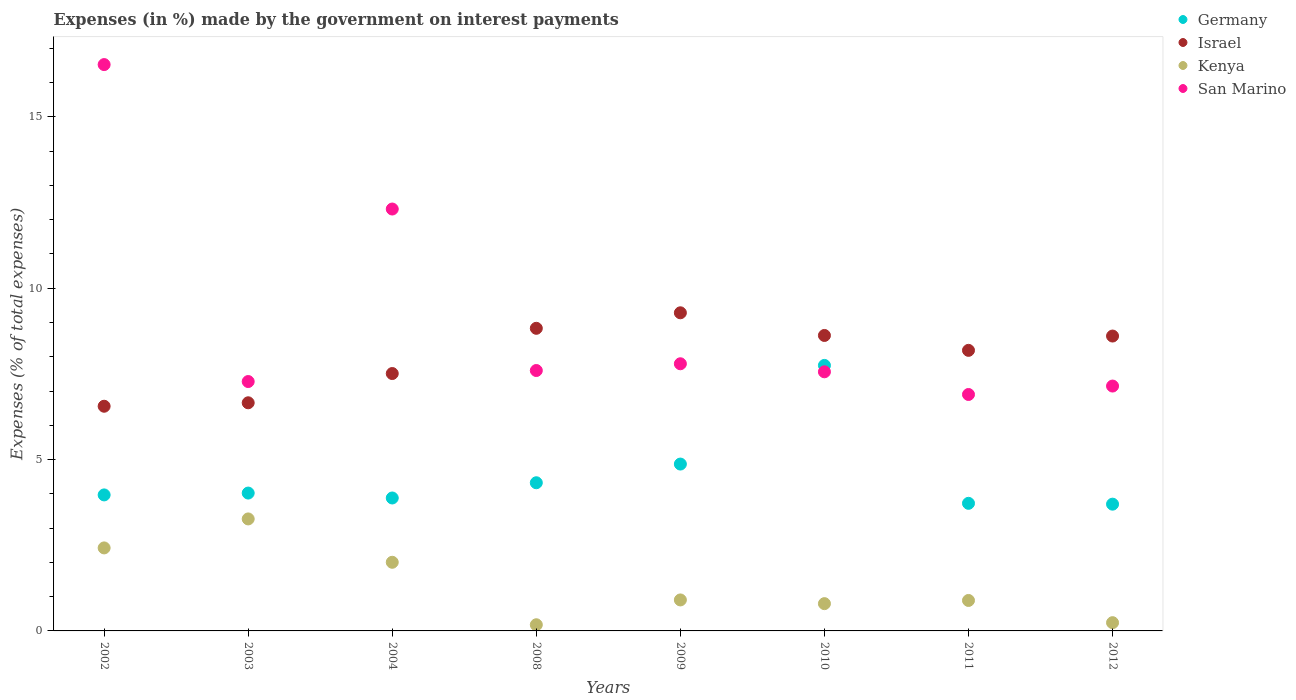How many different coloured dotlines are there?
Your response must be concise. 4. Is the number of dotlines equal to the number of legend labels?
Ensure brevity in your answer.  Yes. What is the percentage of expenses made by the government on interest payments in Israel in 2004?
Ensure brevity in your answer.  7.51. Across all years, what is the maximum percentage of expenses made by the government on interest payments in San Marino?
Your response must be concise. 16.53. Across all years, what is the minimum percentage of expenses made by the government on interest payments in Israel?
Give a very brief answer. 6.56. What is the total percentage of expenses made by the government on interest payments in San Marino in the graph?
Provide a succinct answer. 73.12. What is the difference between the percentage of expenses made by the government on interest payments in Germany in 2004 and that in 2009?
Provide a short and direct response. -0.99. What is the difference between the percentage of expenses made by the government on interest payments in San Marino in 2011 and the percentage of expenses made by the government on interest payments in Israel in 2003?
Provide a succinct answer. 0.24. What is the average percentage of expenses made by the government on interest payments in Kenya per year?
Provide a succinct answer. 1.34. In the year 2008, what is the difference between the percentage of expenses made by the government on interest payments in Kenya and percentage of expenses made by the government on interest payments in San Marino?
Provide a short and direct response. -7.42. What is the ratio of the percentage of expenses made by the government on interest payments in Israel in 2002 to that in 2008?
Your answer should be very brief. 0.74. Is the percentage of expenses made by the government on interest payments in San Marino in 2003 less than that in 2012?
Make the answer very short. No. What is the difference between the highest and the second highest percentage of expenses made by the government on interest payments in San Marino?
Offer a very short reply. 4.22. What is the difference between the highest and the lowest percentage of expenses made by the government on interest payments in Israel?
Your response must be concise. 2.73. In how many years, is the percentage of expenses made by the government on interest payments in San Marino greater than the average percentage of expenses made by the government on interest payments in San Marino taken over all years?
Your response must be concise. 2. Is the sum of the percentage of expenses made by the government on interest payments in Germany in 2011 and 2012 greater than the maximum percentage of expenses made by the government on interest payments in Kenya across all years?
Keep it short and to the point. Yes. Is it the case that in every year, the sum of the percentage of expenses made by the government on interest payments in Israel and percentage of expenses made by the government on interest payments in Germany  is greater than the percentage of expenses made by the government on interest payments in Kenya?
Give a very brief answer. Yes. Is the percentage of expenses made by the government on interest payments in Germany strictly greater than the percentage of expenses made by the government on interest payments in Israel over the years?
Offer a terse response. No. Is the percentage of expenses made by the government on interest payments in Kenya strictly less than the percentage of expenses made by the government on interest payments in Germany over the years?
Give a very brief answer. Yes. Does the graph contain any zero values?
Ensure brevity in your answer.  No. Where does the legend appear in the graph?
Ensure brevity in your answer.  Top right. How many legend labels are there?
Offer a terse response. 4. What is the title of the graph?
Provide a succinct answer. Expenses (in %) made by the government on interest payments. What is the label or title of the X-axis?
Provide a succinct answer. Years. What is the label or title of the Y-axis?
Give a very brief answer. Expenses (% of total expenses). What is the Expenses (% of total expenses) of Germany in 2002?
Make the answer very short. 3.97. What is the Expenses (% of total expenses) in Israel in 2002?
Make the answer very short. 6.56. What is the Expenses (% of total expenses) in Kenya in 2002?
Offer a very short reply. 2.42. What is the Expenses (% of total expenses) in San Marino in 2002?
Give a very brief answer. 16.53. What is the Expenses (% of total expenses) of Germany in 2003?
Give a very brief answer. 4.02. What is the Expenses (% of total expenses) of Israel in 2003?
Ensure brevity in your answer.  6.66. What is the Expenses (% of total expenses) in Kenya in 2003?
Offer a terse response. 3.27. What is the Expenses (% of total expenses) of San Marino in 2003?
Your response must be concise. 7.28. What is the Expenses (% of total expenses) of Germany in 2004?
Keep it short and to the point. 3.88. What is the Expenses (% of total expenses) of Israel in 2004?
Make the answer very short. 7.51. What is the Expenses (% of total expenses) of Kenya in 2004?
Keep it short and to the point. 2. What is the Expenses (% of total expenses) of San Marino in 2004?
Make the answer very short. 12.31. What is the Expenses (% of total expenses) of Germany in 2008?
Offer a very short reply. 4.32. What is the Expenses (% of total expenses) in Israel in 2008?
Your response must be concise. 8.83. What is the Expenses (% of total expenses) in Kenya in 2008?
Keep it short and to the point. 0.18. What is the Expenses (% of total expenses) in San Marino in 2008?
Offer a very short reply. 7.6. What is the Expenses (% of total expenses) in Germany in 2009?
Provide a short and direct response. 4.87. What is the Expenses (% of total expenses) of Israel in 2009?
Your answer should be very brief. 9.28. What is the Expenses (% of total expenses) of Kenya in 2009?
Offer a terse response. 0.9. What is the Expenses (% of total expenses) in San Marino in 2009?
Make the answer very short. 7.8. What is the Expenses (% of total expenses) of Germany in 2010?
Offer a terse response. 7.75. What is the Expenses (% of total expenses) in Israel in 2010?
Your response must be concise. 8.62. What is the Expenses (% of total expenses) in Kenya in 2010?
Keep it short and to the point. 0.8. What is the Expenses (% of total expenses) of San Marino in 2010?
Offer a very short reply. 7.56. What is the Expenses (% of total expenses) of Germany in 2011?
Ensure brevity in your answer.  3.72. What is the Expenses (% of total expenses) in Israel in 2011?
Offer a very short reply. 8.19. What is the Expenses (% of total expenses) in Kenya in 2011?
Give a very brief answer. 0.89. What is the Expenses (% of total expenses) of San Marino in 2011?
Offer a terse response. 6.9. What is the Expenses (% of total expenses) of Germany in 2012?
Give a very brief answer. 3.7. What is the Expenses (% of total expenses) in Israel in 2012?
Make the answer very short. 8.61. What is the Expenses (% of total expenses) in Kenya in 2012?
Make the answer very short. 0.24. What is the Expenses (% of total expenses) of San Marino in 2012?
Make the answer very short. 7.15. Across all years, what is the maximum Expenses (% of total expenses) in Germany?
Your answer should be compact. 7.75. Across all years, what is the maximum Expenses (% of total expenses) of Israel?
Offer a terse response. 9.28. Across all years, what is the maximum Expenses (% of total expenses) of Kenya?
Keep it short and to the point. 3.27. Across all years, what is the maximum Expenses (% of total expenses) in San Marino?
Offer a very short reply. 16.53. Across all years, what is the minimum Expenses (% of total expenses) in Germany?
Give a very brief answer. 3.7. Across all years, what is the minimum Expenses (% of total expenses) of Israel?
Offer a terse response. 6.56. Across all years, what is the minimum Expenses (% of total expenses) of Kenya?
Make the answer very short. 0.18. Across all years, what is the minimum Expenses (% of total expenses) of San Marino?
Your answer should be very brief. 6.9. What is the total Expenses (% of total expenses) in Germany in the graph?
Your answer should be compact. 36.24. What is the total Expenses (% of total expenses) in Israel in the graph?
Make the answer very short. 64.26. What is the total Expenses (% of total expenses) of Kenya in the graph?
Make the answer very short. 10.7. What is the total Expenses (% of total expenses) in San Marino in the graph?
Your response must be concise. 73.12. What is the difference between the Expenses (% of total expenses) in Germany in 2002 and that in 2003?
Keep it short and to the point. -0.05. What is the difference between the Expenses (% of total expenses) of Israel in 2002 and that in 2003?
Offer a terse response. -0.1. What is the difference between the Expenses (% of total expenses) in Kenya in 2002 and that in 2003?
Offer a very short reply. -0.85. What is the difference between the Expenses (% of total expenses) in San Marino in 2002 and that in 2003?
Ensure brevity in your answer.  9.25. What is the difference between the Expenses (% of total expenses) of Germany in 2002 and that in 2004?
Make the answer very short. 0.09. What is the difference between the Expenses (% of total expenses) in Israel in 2002 and that in 2004?
Your answer should be compact. -0.95. What is the difference between the Expenses (% of total expenses) of Kenya in 2002 and that in 2004?
Offer a very short reply. 0.42. What is the difference between the Expenses (% of total expenses) of San Marino in 2002 and that in 2004?
Provide a short and direct response. 4.22. What is the difference between the Expenses (% of total expenses) in Germany in 2002 and that in 2008?
Offer a terse response. -0.35. What is the difference between the Expenses (% of total expenses) of Israel in 2002 and that in 2008?
Ensure brevity in your answer.  -2.27. What is the difference between the Expenses (% of total expenses) in Kenya in 2002 and that in 2008?
Give a very brief answer. 2.24. What is the difference between the Expenses (% of total expenses) in San Marino in 2002 and that in 2008?
Provide a short and direct response. 8.93. What is the difference between the Expenses (% of total expenses) of Germany in 2002 and that in 2009?
Your response must be concise. -0.9. What is the difference between the Expenses (% of total expenses) of Israel in 2002 and that in 2009?
Give a very brief answer. -2.73. What is the difference between the Expenses (% of total expenses) of Kenya in 2002 and that in 2009?
Ensure brevity in your answer.  1.52. What is the difference between the Expenses (% of total expenses) of San Marino in 2002 and that in 2009?
Offer a very short reply. 8.73. What is the difference between the Expenses (% of total expenses) in Germany in 2002 and that in 2010?
Give a very brief answer. -3.78. What is the difference between the Expenses (% of total expenses) of Israel in 2002 and that in 2010?
Provide a succinct answer. -2.07. What is the difference between the Expenses (% of total expenses) of Kenya in 2002 and that in 2010?
Your answer should be compact. 1.63. What is the difference between the Expenses (% of total expenses) of San Marino in 2002 and that in 2010?
Give a very brief answer. 8.97. What is the difference between the Expenses (% of total expenses) in Germany in 2002 and that in 2011?
Your response must be concise. 0.25. What is the difference between the Expenses (% of total expenses) in Israel in 2002 and that in 2011?
Provide a short and direct response. -1.63. What is the difference between the Expenses (% of total expenses) in Kenya in 2002 and that in 2011?
Make the answer very short. 1.53. What is the difference between the Expenses (% of total expenses) of San Marino in 2002 and that in 2011?
Provide a short and direct response. 9.63. What is the difference between the Expenses (% of total expenses) in Germany in 2002 and that in 2012?
Offer a very short reply. 0.27. What is the difference between the Expenses (% of total expenses) in Israel in 2002 and that in 2012?
Make the answer very short. -2.05. What is the difference between the Expenses (% of total expenses) of Kenya in 2002 and that in 2012?
Your answer should be very brief. 2.18. What is the difference between the Expenses (% of total expenses) of San Marino in 2002 and that in 2012?
Give a very brief answer. 9.38. What is the difference between the Expenses (% of total expenses) of Germany in 2003 and that in 2004?
Provide a succinct answer. 0.14. What is the difference between the Expenses (% of total expenses) in Israel in 2003 and that in 2004?
Offer a very short reply. -0.85. What is the difference between the Expenses (% of total expenses) of Kenya in 2003 and that in 2004?
Make the answer very short. 1.27. What is the difference between the Expenses (% of total expenses) of San Marino in 2003 and that in 2004?
Provide a short and direct response. -5.03. What is the difference between the Expenses (% of total expenses) of Germany in 2003 and that in 2008?
Your answer should be very brief. -0.3. What is the difference between the Expenses (% of total expenses) of Israel in 2003 and that in 2008?
Offer a terse response. -2.17. What is the difference between the Expenses (% of total expenses) of Kenya in 2003 and that in 2008?
Offer a very short reply. 3.09. What is the difference between the Expenses (% of total expenses) in San Marino in 2003 and that in 2008?
Offer a very short reply. -0.32. What is the difference between the Expenses (% of total expenses) in Germany in 2003 and that in 2009?
Offer a very short reply. -0.85. What is the difference between the Expenses (% of total expenses) in Israel in 2003 and that in 2009?
Give a very brief answer. -2.63. What is the difference between the Expenses (% of total expenses) in Kenya in 2003 and that in 2009?
Make the answer very short. 2.36. What is the difference between the Expenses (% of total expenses) in San Marino in 2003 and that in 2009?
Your response must be concise. -0.52. What is the difference between the Expenses (% of total expenses) of Germany in 2003 and that in 2010?
Make the answer very short. -3.73. What is the difference between the Expenses (% of total expenses) of Israel in 2003 and that in 2010?
Ensure brevity in your answer.  -1.96. What is the difference between the Expenses (% of total expenses) of Kenya in 2003 and that in 2010?
Your answer should be compact. 2.47. What is the difference between the Expenses (% of total expenses) in San Marino in 2003 and that in 2010?
Your response must be concise. -0.28. What is the difference between the Expenses (% of total expenses) in Germany in 2003 and that in 2011?
Offer a terse response. 0.3. What is the difference between the Expenses (% of total expenses) of Israel in 2003 and that in 2011?
Offer a very short reply. -1.53. What is the difference between the Expenses (% of total expenses) in Kenya in 2003 and that in 2011?
Your answer should be compact. 2.38. What is the difference between the Expenses (% of total expenses) of San Marino in 2003 and that in 2011?
Offer a very short reply. 0.38. What is the difference between the Expenses (% of total expenses) in Germany in 2003 and that in 2012?
Provide a short and direct response. 0.32. What is the difference between the Expenses (% of total expenses) in Israel in 2003 and that in 2012?
Provide a short and direct response. -1.95. What is the difference between the Expenses (% of total expenses) in Kenya in 2003 and that in 2012?
Offer a very short reply. 3.03. What is the difference between the Expenses (% of total expenses) of San Marino in 2003 and that in 2012?
Your answer should be compact. 0.13. What is the difference between the Expenses (% of total expenses) of Germany in 2004 and that in 2008?
Your answer should be compact. -0.44. What is the difference between the Expenses (% of total expenses) in Israel in 2004 and that in 2008?
Ensure brevity in your answer.  -1.32. What is the difference between the Expenses (% of total expenses) of Kenya in 2004 and that in 2008?
Your answer should be compact. 1.82. What is the difference between the Expenses (% of total expenses) in San Marino in 2004 and that in 2008?
Your answer should be compact. 4.71. What is the difference between the Expenses (% of total expenses) in Germany in 2004 and that in 2009?
Your response must be concise. -0.99. What is the difference between the Expenses (% of total expenses) in Israel in 2004 and that in 2009?
Keep it short and to the point. -1.77. What is the difference between the Expenses (% of total expenses) in Kenya in 2004 and that in 2009?
Provide a succinct answer. 1.1. What is the difference between the Expenses (% of total expenses) of San Marino in 2004 and that in 2009?
Offer a very short reply. 4.52. What is the difference between the Expenses (% of total expenses) in Germany in 2004 and that in 2010?
Your answer should be compact. -3.87. What is the difference between the Expenses (% of total expenses) of Israel in 2004 and that in 2010?
Provide a succinct answer. -1.11. What is the difference between the Expenses (% of total expenses) in Kenya in 2004 and that in 2010?
Your answer should be very brief. 1.21. What is the difference between the Expenses (% of total expenses) in San Marino in 2004 and that in 2010?
Make the answer very short. 4.75. What is the difference between the Expenses (% of total expenses) in Germany in 2004 and that in 2011?
Provide a short and direct response. 0.16. What is the difference between the Expenses (% of total expenses) in Israel in 2004 and that in 2011?
Ensure brevity in your answer.  -0.68. What is the difference between the Expenses (% of total expenses) of Kenya in 2004 and that in 2011?
Give a very brief answer. 1.11. What is the difference between the Expenses (% of total expenses) of San Marino in 2004 and that in 2011?
Offer a very short reply. 5.41. What is the difference between the Expenses (% of total expenses) of Germany in 2004 and that in 2012?
Your response must be concise. 0.18. What is the difference between the Expenses (% of total expenses) in Israel in 2004 and that in 2012?
Ensure brevity in your answer.  -1.09. What is the difference between the Expenses (% of total expenses) of Kenya in 2004 and that in 2012?
Make the answer very short. 1.76. What is the difference between the Expenses (% of total expenses) in San Marino in 2004 and that in 2012?
Your response must be concise. 5.17. What is the difference between the Expenses (% of total expenses) of Germany in 2008 and that in 2009?
Your response must be concise. -0.55. What is the difference between the Expenses (% of total expenses) in Israel in 2008 and that in 2009?
Offer a very short reply. -0.45. What is the difference between the Expenses (% of total expenses) of Kenya in 2008 and that in 2009?
Keep it short and to the point. -0.72. What is the difference between the Expenses (% of total expenses) of San Marino in 2008 and that in 2009?
Your response must be concise. -0.2. What is the difference between the Expenses (% of total expenses) in Germany in 2008 and that in 2010?
Make the answer very short. -3.42. What is the difference between the Expenses (% of total expenses) of Israel in 2008 and that in 2010?
Your answer should be compact. 0.21. What is the difference between the Expenses (% of total expenses) of Kenya in 2008 and that in 2010?
Your answer should be very brief. -0.62. What is the difference between the Expenses (% of total expenses) in San Marino in 2008 and that in 2010?
Offer a very short reply. 0.04. What is the difference between the Expenses (% of total expenses) in Germany in 2008 and that in 2011?
Provide a short and direct response. 0.6. What is the difference between the Expenses (% of total expenses) in Israel in 2008 and that in 2011?
Your answer should be very brief. 0.64. What is the difference between the Expenses (% of total expenses) in Kenya in 2008 and that in 2011?
Your response must be concise. -0.71. What is the difference between the Expenses (% of total expenses) of San Marino in 2008 and that in 2011?
Ensure brevity in your answer.  0.7. What is the difference between the Expenses (% of total expenses) in Germany in 2008 and that in 2012?
Offer a terse response. 0.62. What is the difference between the Expenses (% of total expenses) in Israel in 2008 and that in 2012?
Give a very brief answer. 0.23. What is the difference between the Expenses (% of total expenses) of Kenya in 2008 and that in 2012?
Your answer should be compact. -0.06. What is the difference between the Expenses (% of total expenses) in San Marino in 2008 and that in 2012?
Provide a succinct answer. 0.45. What is the difference between the Expenses (% of total expenses) of Germany in 2009 and that in 2010?
Ensure brevity in your answer.  -2.88. What is the difference between the Expenses (% of total expenses) of Israel in 2009 and that in 2010?
Ensure brevity in your answer.  0.66. What is the difference between the Expenses (% of total expenses) in Kenya in 2009 and that in 2010?
Your response must be concise. 0.11. What is the difference between the Expenses (% of total expenses) of San Marino in 2009 and that in 2010?
Your answer should be very brief. 0.23. What is the difference between the Expenses (% of total expenses) of Germany in 2009 and that in 2011?
Keep it short and to the point. 1.15. What is the difference between the Expenses (% of total expenses) in Israel in 2009 and that in 2011?
Give a very brief answer. 1.1. What is the difference between the Expenses (% of total expenses) in Kenya in 2009 and that in 2011?
Your response must be concise. 0.02. What is the difference between the Expenses (% of total expenses) of San Marino in 2009 and that in 2011?
Provide a succinct answer. 0.9. What is the difference between the Expenses (% of total expenses) in Germany in 2009 and that in 2012?
Your response must be concise. 1.17. What is the difference between the Expenses (% of total expenses) of Israel in 2009 and that in 2012?
Your response must be concise. 0.68. What is the difference between the Expenses (% of total expenses) in Kenya in 2009 and that in 2012?
Provide a short and direct response. 0.66. What is the difference between the Expenses (% of total expenses) in San Marino in 2009 and that in 2012?
Your answer should be compact. 0.65. What is the difference between the Expenses (% of total expenses) of Germany in 2010 and that in 2011?
Offer a terse response. 4.02. What is the difference between the Expenses (% of total expenses) of Israel in 2010 and that in 2011?
Make the answer very short. 0.43. What is the difference between the Expenses (% of total expenses) of Kenya in 2010 and that in 2011?
Ensure brevity in your answer.  -0.09. What is the difference between the Expenses (% of total expenses) of San Marino in 2010 and that in 2011?
Keep it short and to the point. 0.66. What is the difference between the Expenses (% of total expenses) in Germany in 2010 and that in 2012?
Offer a terse response. 4.05. What is the difference between the Expenses (% of total expenses) of Israel in 2010 and that in 2012?
Ensure brevity in your answer.  0.02. What is the difference between the Expenses (% of total expenses) of Kenya in 2010 and that in 2012?
Ensure brevity in your answer.  0.56. What is the difference between the Expenses (% of total expenses) of San Marino in 2010 and that in 2012?
Ensure brevity in your answer.  0.42. What is the difference between the Expenses (% of total expenses) in Germany in 2011 and that in 2012?
Keep it short and to the point. 0.02. What is the difference between the Expenses (% of total expenses) of Israel in 2011 and that in 2012?
Offer a terse response. -0.42. What is the difference between the Expenses (% of total expenses) of Kenya in 2011 and that in 2012?
Offer a terse response. 0.65. What is the difference between the Expenses (% of total expenses) in San Marino in 2011 and that in 2012?
Give a very brief answer. -0.25. What is the difference between the Expenses (% of total expenses) of Germany in 2002 and the Expenses (% of total expenses) of Israel in 2003?
Keep it short and to the point. -2.69. What is the difference between the Expenses (% of total expenses) of Germany in 2002 and the Expenses (% of total expenses) of Kenya in 2003?
Make the answer very short. 0.7. What is the difference between the Expenses (% of total expenses) in Germany in 2002 and the Expenses (% of total expenses) in San Marino in 2003?
Provide a succinct answer. -3.31. What is the difference between the Expenses (% of total expenses) of Israel in 2002 and the Expenses (% of total expenses) of Kenya in 2003?
Your answer should be very brief. 3.29. What is the difference between the Expenses (% of total expenses) of Israel in 2002 and the Expenses (% of total expenses) of San Marino in 2003?
Your response must be concise. -0.72. What is the difference between the Expenses (% of total expenses) in Kenya in 2002 and the Expenses (% of total expenses) in San Marino in 2003?
Offer a terse response. -4.86. What is the difference between the Expenses (% of total expenses) of Germany in 2002 and the Expenses (% of total expenses) of Israel in 2004?
Offer a very short reply. -3.54. What is the difference between the Expenses (% of total expenses) in Germany in 2002 and the Expenses (% of total expenses) in Kenya in 2004?
Your answer should be very brief. 1.97. What is the difference between the Expenses (% of total expenses) of Germany in 2002 and the Expenses (% of total expenses) of San Marino in 2004?
Provide a short and direct response. -8.34. What is the difference between the Expenses (% of total expenses) of Israel in 2002 and the Expenses (% of total expenses) of Kenya in 2004?
Your answer should be compact. 4.55. What is the difference between the Expenses (% of total expenses) of Israel in 2002 and the Expenses (% of total expenses) of San Marino in 2004?
Provide a short and direct response. -5.76. What is the difference between the Expenses (% of total expenses) of Kenya in 2002 and the Expenses (% of total expenses) of San Marino in 2004?
Provide a succinct answer. -9.89. What is the difference between the Expenses (% of total expenses) in Germany in 2002 and the Expenses (% of total expenses) in Israel in 2008?
Offer a very short reply. -4.86. What is the difference between the Expenses (% of total expenses) of Germany in 2002 and the Expenses (% of total expenses) of Kenya in 2008?
Your answer should be compact. 3.79. What is the difference between the Expenses (% of total expenses) of Germany in 2002 and the Expenses (% of total expenses) of San Marino in 2008?
Your answer should be very brief. -3.63. What is the difference between the Expenses (% of total expenses) in Israel in 2002 and the Expenses (% of total expenses) in Kenya in 2008?
Your answer should be compact. 6.38. What is the difference between the Expenses (% of total expenses) of Israel in 2002 and the Expenses (% of total expenses) of San Marino in 2008?
Offer a terse response. -1.04. What is the difference between the Expenses (% of total expenses) of Kenya in 2002 and the Expenses (% of total expenses) of San Marino in 2008?
Make the answer very short. -5.18. What is the difference between the Expenses (% of total expenses) in Germany in 2002 and the Expenses (% of total expenses) in Israel in 2009?
Provide a succinct answer. -5.31. What is the difference between the Expenses (% of total expenses) in Germany in 2002 and the Expenses (% of total expenses) in Kenya in 2009?
Your answer should be compact. 3.06. What is the difference between the Expenses (% of total expenses) of Germany in 2002 and the Expenses (% of total expenses) of San Marino in 2009?
Offer a terse response. -3.83. What is the difference between the Expenses (% of total expenses) of Israel in 2002 and the Expenses (% of total expenses) of Kenya in 2009?
Offer a very short reply. 5.65. What is the difference between the Expenses (% of total expenses) of Israel in 2002 and the Expenses (% of total expenses) of San Marino in 2009?
Make the answer very short. -1.24. What is the difference between the Expenses (% of total expenses) of Kenya in 2002 and the Expenses (% of total expenses) of San Marino in 2009?
Give a very brief answer. -5.37. What is the difference between the Expenses (% of total expenses) in Germany in 2002 and the Expenses (% of total expenses) in Israel in 2010?
Offer a terse response. -4.65. What is the difference between the Expenses (% of total expenses) in Germany in 2002 and the Expenses (% of total expenses) in Kenya in 2010?
Ensure brevity in your answer.  3.17. What is the difference between the Expenses (% of total expenses) of Germany in 2002 and the Expenses (% of total expenses) of San Marino in 2010?
Provide a succinct answer. -3.59. What is the difference between the Expenses (% of total expenses) of Israel in 2002 and the Expenses (% of total expenses) of Kenya in 2010?
Offer a terse response. 5.76. What is the difference between the Expenses (% of total expenses) of Israel in 2002 and the Expenses (% of total expenses) of San Marino in 2010?
Offer a very short reply. -1. What is the difference between the Expenses (% of total expenses) in Kenya in 2002 and the Expenses (% of total expenses) in San Marino in 2010?
Provide a short and direct response. -5.14. What is the difference between the Expenses (% of total expenses) in Germany in 2002 and the Expenses (% of total expenses) in Israel in 2011?
Keep it short and to the point. -4.22. What is the difference between the Expenses (% of total expenses) of Germany in 2002 and the Expenses (% of total expenses) of Kenya in 2011?
Provide a short and direct response. 3.08. What is the difference between the Expenses (% of total expenses) in Germany in 2002 and the Expenses (% of total expenses) in San Marino in 2011?
Your answer should be compact. -2.93. What is the difference between the Expenses (% of total expenses) of Israel in 2002 and the Expenses (% of total expenses) of Kenya in 2011?
Your answer should be compact. 5.67. What is the difference between the Expenses (% of total expenses) in Israel in 2002 and the Expenses (% of total expenses) in San Marino in 2011?
Your answer should be compact. -0.34. What is the difference between the Expenses (% of total expenses) of Kenya in 2002 and the Expenses (% of total expenses) of San Marino in 2011?
Give a very brief answer. -4.48. What is the difference between the Expenses (% of total expenses) of Germany in 2002 and the Expenses (% of total expenses) of Israel in 2012?
Your response must be concise. -4.64. What is the difference between the Expenses (% of total expenses) of Germany in 2002 and the Expenses (% of total expenses) of Kenya in 2012?
Provide a short and direct response. 3.73. What is the difference between the Expenses (% of total expenses) in Germany in 2002 and the Expenses (% of total expenses) in San Marino in 2012?
Offer a very short reply. -3.18. What is the difference between the Expenses (% of total expenses) in Israel in 2002 and the Expenses (% of total expenses) in Kenya in 2012?
Provide a short and direct response. 6.32. What is the difference between the Expenses (% of total expenses) of Israel in 2002 and the Expenses (% of total expenses) of San Marino in 2012?
Your answer should be very brief. -0.59. What is the difference between the Expenses (% of total expenses) of Kenya in 2002 and the Expenses (% of total expenses) of San Marino in 2012?
Offer a very short reply. -4.72. What is the difference between the Expenses (% of total expenses) of Germany in 2003 and the Expenses (% of total expenses) of Israel in 2004?
Provide a short and direct response. -3.49. What is the difference between the Expenses (% of total expenses) of Germany in 2003 and the Expenses (% of total expenses) of Kenya in 2004?
Offer a terse response. 2.02. What is the difference between the Expenses (% of total expenses) in Germany in 2003 and the Expenses (% of total expenses) in San Marino in 2004?
Keep it short and to the point. -8.29. What is the difference between the Expenses (% of total expenses) of Israel in 2003 and the Expenses (% of total expenses) of Kenya in 2004?
Ensure brevity in your answer.  4.65. What is the difference between the Expenses (% of total expenses) of Israel in 2003 and the Expenses (% of total expenses) of San Marino in 2004?
Ensure brevity in your answer.  -5.65. What is the difference between the Expenses (% of total expenses) of Kenya in 2003 and the Expenses (% of total expenses) of San Marino in 2004?
Provide a short and direct response. -9.04. What is the difference between the Expenses (% of total expenses) of Germany in 2003 and the Expenses (% of total expenses) of Israel in 2008?
Your response must be concise. -4.81. What is the difference between the Expenses (% of total expenses) in Germany in 2003 and the Expenses (% of total expenses) in Kenya in 2008?
Ensure brevity in your answer.  3.84. What is the difference between the Expenses (% of total expenses) in Germany in 2003 and the Expenses (% of total expenses) in San Marino in 2008?
Offer a very short reply. -3.58. What is the difference between the Expenses (% of total expenses) of Israel in 2003 and the Expenses (% of total expenses) of Kenya in 2008?
Offer a terse response. 6.48. What is the difference between the Expenses (% of total expenses) of Israel in 2003 and the Expenses (% of total expenses) of San Marino in 2008?
Offer a very short reply. -0.94. What is the difference between the Expenses (% of total expenses) of Kenya in 2003 and the Expenses (% of total expenses) of San Marino in 2008?
Provide a short and direct response. -4.33. What is the difference between the Expenses (% of total expenses) in Germany in 2003 and the Expenses (% of total expenses) in Israel in 2009?
Your answer should be compact. -5.26. What is the difference between the Expenses (% of total expenses) of Germany in 2003 and the Expenses (% of total expenses) of Kenya in 2009?
Keep it short and to the point. 3.12. What is the difference between the Expenses (% of total expenses) of Germany in 2003 and the Expenses (% of total expenses) of San Marino in 2009?
Your answer should be compact. -3.77. What is the difference between the Expenses (% of total expenses) in Israel in 2003 and the Expenses (% of total expenses) in Kenya in 2009?
Ensure brevity in your answer.  5.75. What is the difference between the Expenses (% of total expenses) in Israel in 2003 and the Expenses (% of total expenses) in San Marino in 2009?
Offer a very short reply. -1.14. What is the difference between the Expenses (% of total expenses) of Kenya in 2003 and the Expenses (% of total expenses) of San Marino in 2009?
Ensure brevity in your answer.  -4.53. What is the difference between the Expenses (% of total expenses) in Germany in 2003 and the Expenses (% of total expenses) in Israel in 2010?
Keep it short and to the point. -4.6. What is the difference between the Expenses (% of total expenses) of Germany in 2003 and the Expenses (% of total expenses) of Kenya in 2010?
Ensure brevity in your answer.  3.23. What is the difference between the Expenses (% of total expenses) in Germany in 2003 and the Expenses (% of total expenses) in San Marino in 2010?
Your answer should be very brief. -3.54. What is the difference between the Expenses (% of total expenses) of Israel in 2003 and the Expenses (% of total expenses) of Kenya in 2010?
Ensure brevity in your answer.  5.86. What is the difference between the Expenses (% of total expenses) in Israel in 2003 and the Expenses (% of total expenses) in San Marino in 2010?
Make the answer very short. -0.9. What is the difference between the Expenses (% of total expenses) of Kenya in 2003 and the Expenses (% of total expenses) of San Marino in 2010?
Your response must be concise. -4.29. What is the difference between the Expenses (% of total expenses) of Germany in 2003 and the Expenses (% of total expenses) of Israel in 2011?
Offer a terse response. -4.16. What is the difference between the Expenses (% of total expenses) of Germany in 2003 and the Expenses (% of total expenses) of Kenya in 2011?
Give a very brief answer. 3.13. What is the difference between the Expenses (% of total expenses) of Germany in 2003 and the Expenses (% of total expenses) of San Marino in 2011?
Keep it short and to the point. -2.88. What is the difference between the Expenses (% of total expenses) of Israel in 2003 and the Expenses (% of total expenses) of Kenya in 2011?
Your answer should be very brief. 5.77. What is the difference between the Expenses (% of total expenses) of Israel in 2003 and the Expenses (% of total expenses) of San Marino in 2011?
Give a very brief answer. -0.24. What is the difference between the Expenses (% of total expenses) in Kenya in 2003 and the Expenses (% of total expenses) in San Marino in 2011?
Offer a very short reply. -3.63. What is the difference between the Expenses (% of total expenses) in Germany in 2003 and the Expenses (% of total expenses) in Israel in 2012?
Your answer should be compact. -4.58. What is the difference between the Expenses (% of total expenses) of Germany in 2003 and the Expenses (% of total expenses) of Kenya in 2012?
Offer a terse response. 3.78. What is the difference between the Expenses (% of total expenses) in Germany in 2003 and the Expenses (% of total expenses) in San Marino in 2012?
Your answer should be very brief. -3.12. What is the difference between the Expenses (% of total expenses) of Israel in 2003 and the Expenses (% of total expenses) of Kenya in 2012?
Provide a short and direct response. 6.42. What is the difference between the Expenses (% of total expenses) of Israel in 2003 and the Expenses (% of total expenses) of San Marino in 2012?
Offer a terse response. -0.49. What is the difference between the Expenses (% of total expenses) in Kenya in 2003 and the Expenses (% of total expenses) in San Marino in 2012?
Provide a succinct answer. -3.88. What is the difference between the Expenses (% of total expenses) in Germany in 2004 and the Expenses (% of total expenses) in Israel in 2008?
Your answer should be very brief. -4.95. What is the difference between the Expenses (% of total expenses) of Germany in 2004 and the Expenses (% of total expenses) of Kenya in 2008?
Provide a short and direct response. 3.7. What is the difference between the Expenses (% of total expenses) in Germany in 2004 and the Expenses (% of total expenses) in San Marino in 2008?
Ensure brevity in your answer.  -3.72. What is the difference between the Expenses (% of total expenses) in Israel in 2004 and the Expenses (% of total expenses) in Kenya in 2008?
Provide a short and direct response. 7.33. What is the difference between the Expenses (% of total expenses) of Israel in 2004 and the Expenses (% of total expenses) of San Marino in 2008?
Give a very brief answer. -0.09. What is the difference between the Expenses (% of total expenses) in Kenya in 2004 and the Expenses (% of total expenses) in San Marino in 2008?
Your answer should be very brief. -5.6. What is the difference between the Expenses (% of total expenses) of Germany in 2004 and the Expenses (% of total expenses) of Israel in 2009?
Your answer should be very brief. -5.4. What is the difference between the Expenses (% of total expenses) in Germany in 2004 and the Expenses (% of total expenses) in Kenya in 2009?
Give a very brief answer. 2.98. What is the difference between the Expenses (% of total expenses) of Germany in 2004 and the Expenses (% of total expenses) of San Marino in 2009?
Provide a short and direct response. -3.92. What is the difference between the Expenses (% of total expenses) in Israel in 2004 and the Expenses (% of total expenses) in Kenya in 2009?
Ensure brevity in your answer.  6.61. What is the difference between the Expenses (% of total expenses) of Israel in 2004 and the Expenses (% of total expenses) of San Marino in 2009?
Your response must be concise. -0.28. What is the difference between the Expenses (% of total expenses) in Kenya in 2004 and the Expenses (% of total expenses) in San Marino in 2009?
Your answer should be very brief. -5.79. What is the difference between the Expenses (% of total expenses) of Germany in 2004 and the Expenses (% of total expenses) of Israel in 2010?
Give a very brief answer. -4.74. What is the difference between the Expenses (% of total expenses) in Germany in 2004 and the Expenses (% of total expenses) in Kenya in 2010?
Offer a terse response. 3.08. What is the difference between the Expenses (% of total expenses) in Germany in 2004 and the Expenses (% of total expenses) in San Marino in 2010?
Your response must be concise. -3.68. What is the difference between the Expenses (% of total expenses) of Israel in 2004 and the Expenses (% of total expenses) of Kenya in 2010?
Your answer should be compact. 6.72. What is the difference between the Expenses (% of total expenses) of Israel in 2004 and the Expenses (% of total expenses) of San Marino in 2010?
Keep it short and to the point. -0.05. What is the difference between the Expenses (% of total expenses) of Kenya in 2004 and the Expenses (% of total expenses) of San Marino in 2010?
Ensure brevity in your answer.  -5.56. What is the difference between the Expenses (% of total expenses) in Germany in 2004 and the Expenses (% of total expenses) in Israel in 2011?
Make the answer very short. -4.31. What is the difference between the Expenses (% of total expenses) of Germany in 2004 and the Expenses (% of total expenses) of Kenya in 2011?
Provide a short and direct response. 2.99. What is the difference between the Expenses (% of total expenses) in Germany in 2004 and the Expenses (% of total expenses) in San Marino in 2011?
Make the answer very short. -3.02. What is the difference between the Expenses (% of total expenses) in Israel in 2004 and the Expenses (% of total expenses) in Kenya in 2011?
Provide a succinct answer. 6.62. What is the difference between the Expenses (% of total expenses) in Israel in 2004 and the Expenses (% of total expenses) in San Marino in 2011?
Keep it short and to the point. 0.61. What is the difference between the Expenses (% of total expenses) of Kenya in 2004 and the Expenses (% of total expenses) of San Marino in 2011?
Provide a short and direct response. -4.9. What is the difference between the Expenses (% of total expenses) in Germany in 2004 and the Expenses (% of total expenses) in Israel in 2012?
Keep it short and to the point. -4.73. What is the difference between the Expenses (% of total expenses) in Germany in 2004 and the Expenses (% of total expenses) in Kenya in 2012?
Offer a very short reply. 3.64. What is the difference between the Expenses (% of total expenses) in Germany in 2004 and the Expenses (% of total expenses) in San Marino in 2012?
Ensure brevity in your answer.  -3.27. What is the difference between the Expenses (% of total expenses) of Israel in 2004 and the Expenses (% of total expenses) of Kenya in 2012?
Make the answer very short. 7.27. What is the difference between the Expenses (% of total expenses) of Israel in 2004 and the Expenses (% of total expenses) of San Marino in 2012?
Provide a succinct answer. 0.37. What is the difference between the Expenses (% of total expenses) in Kenya in 2004 and the Expenses (% of total expenses) in San Marino in 2012?
Ensure brevity in your answer.  -5.14. What is the difference between the Expenses (% of total expenses) of Germany in 2008 and the Expenses (% of total expenses) of Israel in 2009?
Ensure brevity in your answer.  -4.96. What is the difference between the Expenses (% of total expenses) of Germany in 2008 and the Expenses (% of total expenses) of Kenya in 2009?
Your response must be concise. 3.42. What is the difference between the Expenses (% of total expenses) of Germany in 2008 and the Expenses (% of total expenses) of San Marino in 2009?
Your answer should be compact. -3.47. What is the difference between the Expenses (% of total expenses) of Israel in 2008 and the Expenses (% of total expenses) of Kenya in 2009?
Give a very brief answer. 7.93. What is the difference between the Expenses (% of total expenses) of Israel in 2008 and the Expenses (% of total expenses) of San Marino in 2009?
Provide a short and direct response. 1.03. What is the difference between the Expenses (% of total expenses) in Kenya in 2008 and the Expenses (% of total expenses) in San Marino in 2009?
Your response must be concise. -7.62. What is the difference between the Expenses (% of total expenses) in Germany in 2008 and the Expenses (% of total expenses) in Israel in 2010?
Provide a short and direct response. -4.3. What is the difference between the Expenses (% of total expenses) in Germany in 2008 and the Expenses (% of total expenses) in Kenya in 2010?
Give a very brief answer. 3.53. What is the difference between the Expenses (% of total expenses) in Germany in 2008 and the Expenses (% of total expenses) in San Marino in 2010?
Ensure brevity in your answer.  -3.24. What is the difference between the Expenses (% of total expenses) of Israel in 2008 and the Expenses (% of total expenses) of Kenya in 2010?
Make the answer very short. 8.04. What is the difference between the Expenses (% of total expenses) of Israel in 2008 and the Expenses (% of total expenses) of San Marino in 2010?
Make the answer very short. 1.27. What is the difference between the Expenses (% of total expenses) in Kenya in 2008 and the Expenses (% of total expenses) in San Marino in 2010?
Your response must be concise. -7.38. What is the difference between the Expenses (% of total expenses) in Germany in 2008 and the Expenses (% of total expenses) in Israel in 2011?
Keep it short and to the point. -3.86. What is the difference between the Expenses (% of total expenses) in Germany in 2008 and the Expenses (% of total expenses) in Kenya in 2011?
Offer a terse response. 3.44. What is the difference between the Expenses (% of total expenses) of Germany in 2008 and the Expenses (% of total expenses) of San Marino in 2011?
Keep it short and to the point. -2.58. What is the difference between the Expenses (% of total expenses) in Israel in 2008 and the Expenses (% of total expenses) in Kenya in 2011?
Keep it short and to the point. 7.94. What is the difference between the Expenses (% of total expenses) in Israel in 2008 and the Expenses (% of total expenses) in San Marino in 2011?
Keep it short and to the point. 1.93. What is the difference between the Expenses (% of total expenses) in Kenya in 2008 and the Expenses (% of total expenses) in San Marino in 2011?
Your response must be concise. -6.72. What is the difference between the Expenses (% of total expenses) in Germany in 2008 and the Expenses (% of total expenses) in Israel in 2012?
Provide a succinct answer. -4.28. What is the difference between the Expenses (% of total expenses) in Germany in 2008 and the Expenses (% of total expenses) in Kenya in 2012?
Provide a short and direct response. 4.08. What is the difference between the Expenses (% of total expenses) in Germany in 2008 and the Expenses (% of total expenses) in San Marino in 2012?
Offer a very short reply. -2.82. What is the difference between the Expenses (% of total expenses) in Israel in 2008 and the Expenses (% of total expenses) in Kenya in 2012?
Your answer should be compact. 8.59. What is the difference between the Expenses (% of total expenses) in Israel in 2008 and the Expenses (% of total expenses) in San Marino in 2012?
Keep it short and to the point. 1.69. What is the difference between the Expenses (% of total expenses) in Kenya in 2008 and the Expenses (% of total expenses) in San Marino in 2012?
Your answer should be very brief. -6.97. What is the difference between the Expenses (% of total expenses) of Germany in 2009 and the Expenses (% of total expenses) of Israel in 2010?
Your answer should be compact. -3.75. What is the difference between the Expenses (% of total expenses) in Germany in 2009 and the Expenses (% of total expenses) in Kenya in 2010?
Your answer should be compact. 4.07. What is the difference between the Expenses (% of total expenses) of Germany in 2009 and the Expenses (% of total expenses) of San Marino in 2010?
Provide a succinct answer. -2.69. What is the difference between the Expenses (% of total expenses) in Israel in 2009 and the Expenses (% of total expenses) in Kenya in 2010?
Your answer should be very brief. 8.49. What is the difference between the Expenses (% of total expenses) in Israel in 2009 and the Expenses (% of total expenses) in San Marino in 2010?
Provide a succinct answer. 1.72. What is the difference between the Expenses (% of total expenses) in Kenya in 2009 and the Expenses (% of total expenses) in San Marino in 2010?
Your response must be concise. -6.66. What is the difference between the Expenses (% of total expenses) in Germany in 2009 and the Expenses (% of total expenses) in Israel in 2011?
Offer a terse response. -3.32. What is the difference between the Expenses (% of total expenses) of Germany in 2009 and the Expenses (% of total expenses) of Kenya in 2011?
Make the answer very short. 3.98. What is the difference between the Expenses (% of total expenses) in Germany in 2009 and the Expenses (% of total expenses) in San Marino in 2011?
Your answer should be compact. -2.03. What is the difference between the Expenses (% of total expenses) of Israel in 2009 and the Expenses (% of total expenses) of Kenya in 2011?
Ensure brevity in your answer.  8.39. What is the difference between the Expenses (% of total expenses) in Israel in 2009 and the Expenses (% of total expenses) in San Marino in 2011?
Make the answer very short. 2.38. What is the difference between the Expenses (% of total expenses) of Kenya in 2009 and the Expenses (% of total expenses) of San Marino in 2011?
Give a very brief answer. -6. What is the difference between the Expenses (% of total expenses) in Germany in 2009 and the Expenses (% of total expenses) in Israel in 2012?
Your answer should be very brief. -3.74. What is the difference between the Expenses (% of total expenses) of Germany in 2009 and the Expenses (% of total expenses) of Kenya in 2012?
Keep it short and to the point. 4.63. What is the difference between the Expenses (% of total expenses) of Germany in 2009 and the Expenses (% of total expenses) of San Marino in 2012?
Make the answer very short. -2.28. What is the difference between the Expenses (% of total expenses) of Israel in 2009 and the Expenses (% of total expenses) of Kenya in 2012?
Give a very brief answer. 9.04. What is the difference between the Expenses (% of total expenses) in Israel in 2009 and the Expenses (% of total expenses) in San Marino in 2012?
Your response must be concise. 2.14. What is the difference between the Expenses (% of total expenses) in Kenya in 2009 and the Expenses (% of total expenses) in San Marino in 2012?
Your answer should be very brief. -6.24. What is the difference between the Expenses (% of total expenses) in Germany in 2010 and the Expenses (% of total expenses) in Israel in 2011?
Keep it short and to the point. -0.44. What is the difference between the Expenses (% of total expenses) of Germany in 2010 and the Expenses (% of total expenses) of Kenya in 2011?
Make the answer very short. 6.86. What is the difference between the Expenses (% of total expenses) of Germany in 2010 and the Expenses (% of total expenses) of San Marino in 2011?
Your answer should be very brief. 0.85. What is the difference between the Expenses (% of total expenses) of Israel in 2010 and the Expenses (% of total expenses) of Kenya in 2011?
Your response must be concise. 7.73. What is the difference between the Expenses (% of total expenses) in Israel in 2010 and the Expenses (% of total expenses) in San Marino in 2011?
Keep it short and to the point. 1.72. What is the difference between the Expenses (% of total expenses) in Kenya in 2010 and the Expenses (% of total expenses) in San Marino in 2011?
Make the answer very short. -6.1. What is the difference between the Expenses (% of total expenses) of Germany in 2010 and the Expenses (% of total expenses) of Israel in 2012?
Your answer should be very brief. -0.86. What is the difference between the Expenses (% of total expenses) of Germany in 2010 and the Expenses (% of total expenses) of Kenya in 2012?
Your answer should be compact. 7.51. What is the difference between the Expenses (% of total expenses) of Germany in 2010 and the Expenses (% of total expenses) of San Marino in 2012?
Your answer should be compact. 0.6. What is the difference between the Expenses (% of total expenses) in Israel in 2010 and the Expenses (% of total expenses) in Kenya in 2012?
Give a very brief answer. 8.38. What is the difference between the Expenses (% of total expenses) of Israel in 2010 and the Expenses (% of total expenses) of San Marino in 2012?
Offer a terse response. 1.48. What is the difference between the Expenses (% of total expenses) in Kenya in 2010 and the Expenses (% of total expenses) in San Marino in 2012?
Make the answer very short. -6.35. What is the difference between the Expenses (% of total expenses) of Germany in 2011 and the Expenses (% of total expenses) of Israel in 2012?
Provide a succinct answer. -4.88. What is the difference between the Expenses (% of total expenses) of Germany in 2011 and the Expenses (% of total expenses) of Kenya in 2012?
Offer a very short reply. 3.48. What is the difference between the Expenses (% of total expenses) in Germany in 2011 and the Expenses (% of total expenses) in San Marino in 2012?
Your answer should be compact. -3.42. What is the difference between the Expenses (% of total expenses) of Israel in 2011 and the Expenses (% of total expenses) of Kenya in 2012?
Make the answer very short. 7.95. What is the difference between the Expenses (% of total expenses) of Israel in 2011 and the Expenses (% of total expenses) of San Marino in 2012?
Your response must be concise. 1.04. What is the difference between the Expenses (% of total expenses) of Kenya in 2011 and the Expenses (% of total expenses) of San Marino in 2012?
Provide a short and direct response. -6.26. What is the average Expenses (% of total expenses) of Germany per year?
Offer a very short reply. 4.53. What is the average Expenses (% of total expenses) of Israel per year?
Give a very brief answer. 8.03. What is the average Expenses (% of total expenses) in Kenya per year?
Provide a succinct answer. 1.34. What is the average Expenses (% of total expenses) in San Marino per year?
Provide a short and direct response. 9.14. In the year 2002, what is the difference between the Expenses (% of total expenses) in Germany and Expenses (% of total expenses) in Israel?
Offer a very short reply. -2.59. In the year 2002, what is the difference between the Expenses (% of total expenses) of Germany and Expenses (% of total expenses) of Kenya?
Offer a very short reply. 1.55. In the year 2002, what is the difference between the Expenses (% of total expenses) in Germany and Expenses (% of total expenses) in San Marino?
Your answer should be compact. -12.56. In the year 2002, what is the difference between the Expenses (% of total expenses) in Israel and Expenses (% of total expenses) in Kenya?
Provide a short and direct response. 4.13. In the year 2002, what is the difference between the Expenses (% of total expenses) in Israel and Expenses (% of total expenses) in San Marino?
Your answer should be compact. -9.97. In the year 2002, what is the difference between the Expenses (% of total expenses) in Kenya and Expenses (% of total expenses) in San Marino?
Provide a short and direct response. -14.11. In the year 2003, what is the difference between the Expenses (% of total expenses) in Germany and Expenses (% of total expenses) in Israel?
Provide a short and direct response. -2.63. In the year 2003, what is the difference between the Expenses (% of total expenses) in Germany and Expenses (% of total expenses) in Kenya?
Make the answer very short. 0.75. In the year 2003, what is the difference between the Expenses (% of total expenses) of Germany and Expenses (% of total expenses) of San Marino?
Offer a terse response. -3.25. In the year 2003, what is the difference between the Expenses (% of total expenses) of Israel and Expenses (% of total expenses) of Kenya?
Keep it short and to the point. 3.39. In the year 2003, what is the difference between the Expenses (% of total expenses) of Israel and Expenses (% of total expenses) of San Marino?
Your response must be concise. -0.62. In the year 2003, what is the difference between the Expenses (% of total expenses) of Kenya and Expenses (% of total expenses) of San Marino?
Offer a terse response. -4.01. In the year 2004, what is the difference between the Expenses (% of total expenses) of Germany and Expenses (% of total expenses) of Israel?
Give a very brief answer. -3.63. In the year 2004, what is the difference between the Expenses (% of total expenses) in Germany and Expenses (% of total expenses) in Kenya?
Your answer should be very brief. 1.88. In the year 2004, what is the difference between the Expenses (% of total expenses) of Germany and Expenses (% of total expenses) of San Marino?
Offer a terse response. -8.43. In the year 2004, what is the difference between the Expenses (% of total expenses) of Israel and Expenses (% of total expenses) of Kenya?
Offer a terse response. 5.51. In the year 2004, what is the difference between the Expenses (% of total expenses) in Israel and Expenses (% of total expenses) in San Marino?
Give a very brief answer. -4.8. In the year 2004, what is the difference between the Expenses (% of total expenses) in Kenya and Expenses (% of total expenses) in San Marino?
Offer a terse response. -10.31. In the year 2008, what is the difference between the Expenses (% of total expenses) of Germany and Expenses (% of total expenses) of Israel?
Keep it short and to the point. -4.51. In the year 2008, what is the difference between the Expenses (% of total expenses) in Germany and Expenses (% of total expenses) in Kenya?
Provide a succinct answer. 4.14. In the year 2008, what is the difference between the Expenses (% of total expenses) in Germany and Expenses (% of total expenses) in San Marino?
Provide a succinct answer. -3.28. In the year 2008, what is the difference between the Expenses (% of total expenses) of Israel and Expenses (% of total expenses) of Kenya?
Ensure brevity in your answer.  8.65. In the year 2008, what is the difference between the Expenses (% of total expenses) in Israel and Expenses (% of total expenses) in San Marino?
Offer a terse response. 1.23. In the year 2008, what is the difference between the Expenses (% of total expenses) of Kenya and Expenses (% of total expenses) of San Marino?
Your answer should be compact. -7.42. In the year 2009, what is the difference between the Expenses (% of total expenses) of Germany and Expenses (% of total expenses) of Israel?
Offer a very short reply. -4.41. In the year 2009, what is the difference between the Expenses (% of total expenses) of Germany and Expenses (% of total expenses) of Kenya?
Keep it short and to the point. 3.97. In the year 2009, what is the difference between the Expenses (% of total expenses) of Germany and Expenses (% of total expenses) of San Marino?
Keep it short and to the point. -2.93. In the year 2009, what is the difference between the Expenses (% of total expenses) of Israel and Expenses (% of total expenses) of Kenya?
Offer a very short reply. 8.38. In the year 2009, what is the difference between the Expenses (% of total expenses) in Israel and Expenses (% of total expenses) in San Marino?
Offer a very short reply. 1.49. In the year 2009, what is the difference between the Expenses (% of total expenses) of Kenya and Expenses (% of total expenses) of San Marino?
Give a very brief answer. -6.89. In the year 2010, what is the difference between the Expenses (% of total expenses) of Germany and Expenses (% of total expenses) of Israel?
Ensure brevity in your answer.  -0.87. In the year 2010, what is the difference between the Expenses (% of total expenses) of Germany and Expenses (% of total expenses) of Kenya?
Make the answer very short. 6.95. In the year 2010, what is the difference between the Expenses (% of total expenses) of Germany and Expenses (% of total expenses) of San Marino?
Your answer should be very brief. 0.19. In the year 2010, what is the difference between the Expenses (% of total expenses) of Israel and Expenses (% of total expenses) of Kenya?
Make the answer very short. 7.83. In the year 2010, what is the difference between the Expenses (% of total expenses) of Israel and Expenses (% of total expenses) of San Marino?
Your answer should be compact. 1.06. In the year 2010, what is the difference between the Expenses (% of total expenses) in Kenya and Expenses (% of total expenses) in San Marino?
Provide a short and direct response. -6.77. In the year 2011, what is the difference between the Expenses (% of total expenses) in Germany and Expenses (% of total expenses) in Israel?
Ensure brevity in your answer.  -4.46. In the year 2011, what is the difference between the Expenses (% of total expenses) in Germany and Expenses (% of total expenses) in Kenya?
Your answer should be compact. 2.83. In the year 2011, what is the difference between the Expenses (% of total expenses) of Germany and Expenses (% of total expenses) of San Marino?
Keep it short and to the point. -3.18. In the year 2011, what is the difference between the Expenses (% of total expenses) of Israel and Expenses (% of total expenses) of Kenya?
Provide a succinct answer. 7.3. In the year 2011, what is the difference between the Expenses (% of total expenses) of Israel and Expenses (% of total expenses) of San Marino?
Make the answer very short. 1.29. In the year 2011, what is the difference between the Expenses (% of total expenses) of Kenya and Expenses (% of total expenses) of San Marino?
Provide a short and direct response. -6.01. In the year 2012, what is the difference between the Expenses (% of total expenses) in Germany and Expenses (% of total expenses) in Israel?
Ensure brevity in your answer.  -4.91. In the year 2012, what is the difference between the Expenses (% of total expenses) of Germany and Expenses (% of total expenses) of Kenya?
Give a very brief answer. 3.46. In the year 2012, what is the difference between the Expenses (% of total expenses) in Germany and Expenses (% of total expenses) in San Marino?
Provide a succinct answer. -3.45. In the year 2012, what is the difference between the Expenses (% of total expenses) in Israel and Expenses (% of total expenses) in Kenya?
Your response must be concise. 8.36. In the year 2012, what is the difference between the Expenses (% of total expenses) of Israel and Expenses (% of total expenses) of San Marino?
Your answer should be very brief. 1.46. In the year 2012, what is the difference between the Expenses (% of total expenses) in Kenya and Expenses (% of total expenses) in San Marino?
Provide a succinct answer. -6.91. What is the ratio of the Expenses (% of total expenses) in Germany in 2002 to that in 2003?
Your answer should be very brief. 0.99. What is the ratio of the Expenses (% of total expenses) of Israel in 2002 to that in 2003?
Give a very brief answer. 0.98. What is the ratio of the Expenses (% of total expenses) in Kenya in 2002 to that in 2003?
Offer a very short reply. 0.74. What is the ratio of the Expenses (% of total expenses) in San Marino in 2002 to that in 2003?
Ensure brevity in your answer.  2.27. What is the ratio of the Expenses (% of total expenses) of Germany in 2002 to that in 2004?
Provide a succinct answer. 1.02. What is the ratio of the Expenses (% of total expenses) in Israel in 2002 to that in 2004?
Your response must be concise. 0.87. What is the ratio of the Expenses (% of total expenses) in Kenya in 2002 to that in 2004?
Keep it short and to the point. 1.21. What is the ratio of the Expenses (% of total expenses) in San Marino in 2002 to that in 2004?
Offer a very short reply. 1.34. What is the ratio of the Expenses (% of total expenses) of Germany in 2002 to that in 2008?
Give a very brief answer. 0.92. What is the ratio of the Expenses (% of total expenses) of Israel in 2002 to that in 2008?
Your answer should be compact. 0.74. What is the ratio of the Expenses (% of total expenses) in Kenya in 2002 to that in 2008?
Ensure brevity in your answer.  13.46. What is the ratio of the Expenses (% of total expenses) in San Marino in 2002 to that in 2008?
Make the answer very short. 2.17. What is the ratio of the Expenses (% of total expenses) in Germany in 2002 to that in 2009?
Your answer should be very brief. 0.82. What is the ratio of the Expenses (% of total expenses) of Israel in 2002 to that in 2009?
Make the answer very short. 0.71. What is the ratio of the Expenses (% of total expenses) of Kenya in 2002 to that in 2009?
Offer a terse response. 2.68. What is the ratio of the Expenses (% of total expenses) in San Marino in 2002 to that in 2009?
Offer a very short reply. 2.12. What is the ratio of the Expenses (% of total expenses) of Germany in 2002 to that in 2010?
Your answer should be compact. 0.51. What is the ratio of the Expenses (% of total expenses) of Israel in 2002 to that in 2010?
Offer a terse response. 0.76. What is the ratio of the Expenses (% of total expenses) in Kenya in 2002 to that in 2010?
Keep it short and to the point. 3.04. What is the ratio of the Expenses (% of total expenses) of San Marino in 2002 to that in 2010?
Keep it short and to the point. 2.19. What is the ratio of the Expenses (% of total expenses) in Germany in 2002 to that in 2011?
Give a very brief answer. 1.07. What is the ratio of the Expenses (% of total expenses) of Israel in 2002 to that in 2011?
Ensure brevity in your answer.  0.8. What is the ratio of the Expenses (% of total expenses) in Kenya in 2002 to that in 2011?
Keep it short and to the point. 2.73. What is the ratio of the Expenses (% of total expenses) of San Marino in 2002 to that in 2011?
Offer a very short reply. 2.4. What is the ratio of the Expenses (% of total expenses) in Germany in 2002 to that in 2012?
Provide a succinct answer. 1.07. What is the ratio of the Expenses (% of total expenses) of Israel in 2002 to that in 2012?
Your answer should be compact. 0.76. What is the ratio of the Expenses (% of total expenses) in Kenya in 2002 to that in 2012?
Your response must be concise. 10.07. What is the ratio of the Expenses (% of total expenses) in San Marino in 2002 to that in 2012?
Offer a very short reply. 2.31. What is the ratio of the Expenses (% of total expenses) of Israel in 2003 to that in 2004?
Offer a very short reply. 0.89. What is the ratio of the Expenses (% of total expenses) of Kenya in 2003 to that in 2004?
Offer a very short reply. 1.63. What is the ratio of the Expenses (% of total expenses) in San Marino in 2003 to that in 2004?
Offer a very short reply. 0.59. What is the ratio of the Expenses (% of total expenses) of Germany in 2003 to that in 2008?
Make the answer very short. 0.93. What is the ratio of the Expenses (% of total expenses) in Israel in 2003 to that in 2008?
Give a very brief answer. 0.75. What is the ratio of the Expenses (% of total expenses) in Kenya in 2003 to that in 2008?
Provide a short and direct response. 18.17. What is the ratio of the Expenses (% of total expenses) in San Marino in 2003 to that in 2008?
Your answer should be compact. 0.96. What is the ratio of the Expenses (% of total expenses) of Germany in 2003 to that in 2009?
Provide a short and direct response. 0.83. What is the ratio of the Expenses (% of total expenses) of Israel in 2003 to that in 2009?
Provide a short and direct response. 0.72. What is the ratio of the Expenses (% of total expenses) of Kenya in 2003 to that in 2009?
Provide a short and direct response. 3.61. What is the ratio of the Expenses (% of total expenses) in San Marino in 2003 to that in 2009?
Provide a short and direct response. 0.93. What is the ratio of the Expenses (% of total expenses) in Germany in 2003 to that in 2010?
Give a very brief answer. 0.52. What is the ratio of the Expenses (% of total expenses) in Israel in 2003 to that in 2010?
Make the answer very short. 0.77. What is the ratio of the Expenses (% of total expenses) of Kenya in 2003 to that in 2010?
Give a very brief answer. 4.11. What is the ratio of the Expenses (% of total expenses) of San Marino in 2003 to that in 2010?
Make the answer very short. 0.96. What is the ratio of the Expenses (% of total expenses) in Germany in 2003 to that in 2011?
Your response must be concise. 1.08. What is the ratio of the Expenses (% of total expenses) in Israel in 2003 to that in 2011?
Give a very brief answer. 0.81. What is the ratio of the Expenses (% of total expenses) of Kenya in 2003 to that in 2011?
Provide a short and direct response. 3.68. What is the ratio of the Expenses (% of total expenses) in San Marino in 2003 to that in 2011?
Provide a short and direct response. 1.05. What is the ratio of the Expenses (% of total expenses) of Germany in 2003 to that in 2012?
Offer a terse response. 1.09. What is the ratio of the Expenses (% of total expenses) of Israel in 2003 to that in 2012?
Offer a very short reply. 0.77. What is the ratio of the Expenses (% of total expenses) in Kenya in 2003 to that in 2012?
Keep it short and to the point. 13.59. What is the ratio of the Expenses (% of total expenses) in San Marino in 2003 to that in 2012?
Provide a short and direct response. 1.02. What is the ratio of the Expenses (% of total expenses) of Germany in 2004 to that in 2008?
Your response must be concise. 0.9. What is the ratio of the Expenses (% of total expenses) in Israel in 2004 to that in 2008?
Provide a succinct answer. 0.85. What is the ratio of the Expenses (% of total expenses) of Kenya in 2004 to that in 2008?
Offer a very short reply. 11.13. What is the ratio of the Expenses (% of total expenses) in San Marino in 2004 to that in 2008?
Your response must be concise. 1.62. What is the ratio of the Expenses (% of total expenses) of Germany in 2004 to that in 2009?
Make the answer very short. 0.8. What is the ratio of the Expenses (% of total expenses) of Israel in 2004 to that in 2009?
Ensure brevity in your answer.  0.81. What is the ratio of the Expenses (% of total expenses) of Kenya in 2004 to that in 2009?
Your answer should be compact. 2.22. What is the ratio of the Expenses (% of total expenses) in San Marino in 2004 to that in 2009?
Your answer should be very brief. 1.58. What is the ratio of the Expenses (% of total expenses) in Germany in 2004 to that in 2010?
Provide a succinct answer. 0.5. What is the ratio of the Expenses (% of total expenses) of Israel in 2004 to that in 2010?
Your answer should be compact. 0.87. What is the ratio of the Expenses (% of total expenses) of Kenya in 2004 to that in 2010?
Provide a short and direct response. 2.52. What is the ratio of the Expenses (% of total expenses) in San Marino in 2004 to that in 2010?
Give a very brief answer. 1.63. What is the ratio of the Expenses (% of total expenses) of Germany in 2004 to that in 2011?
Ensure brevity in your answer.  1.04. What is the ratio of the Expenses (% of total expenses) of Israel in 2004 to that in 2011?
Provide a succinct answer. 0.92. What is the ratio of the Expenses (% of total expenses) in Kenya in 2004 to that in 2011?
Your answer should be compact. 2.25. What is the ratio of the Expenses (% of total expenses) of San Marino in 2004 to that in 2011?
Ensure brevity in your answer.  1.78. What is the ratio of the Expenses (% of total expenses) of Germany in 2004 to that in 2012?
Your response must be concise. 1.05. What is the ratio of the Expenses (% of total expenses) in Israel in 2004 to that in 2012?
Your answer should be very brief. 0.87. What is the ratio of the Expenses (% of total expenses) in Kenya in 2004 to that in 2012?
Your answer should be very brief. 8.33. What is the ratio of the Expenses (% of total expenses) in San Marino in 2004 to that in 2012?
Your response must be concise. 1.72. What is the ratio of the Expenses (% of total expenses) of Germany in 2008 to that in 2009?
Provide a succinct answer. 0.89. What is the ratio of the Expenses (% of total expenses) in Israel in 2008 to that in 2009?
Your answer should be very brief. 0.95. What is the ratio of the Expenses (% of total expenses) of Kenya in 2008 to that in 2009?
Your response must be concise. 0.2. What is the ratio of the Expenses (% of total expenses) in San Marino in 2008 to that in 2009?
Your answer should be compact. 0.97. What is the ratio of the Expenses (% of total expenses) of Germany in 2008 to that in 2010?
Offer a terse response. 0.56. What is the ratio of the Expenses (% of total expenses) in Israel in 2008 to that in 2010?
Give a very brief answer. 1.02. What is the ratio of the Expenses (% of total expenses) of Kenya in 2008 to that in 2010?
Your answer should be very brief. 0.23. What is the ratio of the Expenses (% of total expenses) in San Marino in 2008 to that in 2010?
Your answer should be compact. 1. What is the ratio of the Expenses (% of total expenses) of Germany in 2008 to that in 2011?
Offer a terse response. 1.16. What is the ratio of the Expenses (% of total expenses) in Israel in 2008 to that in 2011?
Give a very brief answer. 1.08. What is the ratio of the Expenses (% of total expenses) in Kenya in 2008 to that in 2011?
Provide a succinct answer. 0.2. What is the ratio of the Expenses (% of total expenses) in San Marino in 2008 to that in 2011?
Give a very brief answer. 1.1. What is the ratio of the Expenses (% of total expenses) in Germany in 2008 to that in 2012?
Provide a short and direct response. 1.17. What is the ratio of the Expenses (% of total expenses) in Israel in 2008 to that in 2012?
Your response must be concise. 1.03. What is the ratio of the Expenses (% of total expenses) in Kenya in 2008 to that in 2012?
Give a very brief answer. 0.75. What is the ratio of the Expenses (% of total expenses) in San Marino in 2008 to that in 2012?
Keep it short and to the point. 1.06. What is the ratio of the Expenses (% of total expenses) of Germany in 2009 to that in 2010?
Your response must be concise. 0.63. What is the ratio of the Expenses (% of total expenses) of Israel in 2009 to that in 2010?
Make the answer very short. 1.08. What is the ratio of the Expenses (% of total expenses) of Kenya in 2009 to that in 2010?
Your answer should be very brief. 1.14. What is the ratio of the Expenses (% of total expenses) of San Marino in 2009 to that in 2010?
Keep it short and to the point. 1.03. What is the ratio of the Expenses (% of total expenses) of Germany in 2009 to that in 2011?
Your answer should be very brief. 1.31. What is the ratio of the Expenses (% of total expenses) in Israel in 2009 to that in 2011?
Your answer should be very brief. 1.13. What is the ratio of the Expenses (% of total expenses) of Kenya in 2009 to that in 2011?
Keep it short and to the point. 1.02. What is the ratio of the Expenses (% of total expenses) of San Marino in 2009 to that in 2011?
Give a very brief answer. 1.13. What is the ratio of the Expenses (% of total expenses) of Germany in 2009 to that in 2012?
Make the answer very short. 1.32. What is the ratio of the Expenses (% of total expenses) of Israel in 2009 to that in 2012?
Provide a succinct answer. 1.08. What is the ratio of the Expenses (% of total expenses) of Kenya in 2009 to that in 2012?
Your response must be concise. 3.76. What is the ratio of the Expenses (% of total expenses) of San Marino in 2009 to that in 2012?
Offer a very short reply. 1.09. What is the ratio of the Expenses (% of total expenses) of Germany in 2010 to that in 2011?
Give a very brief answer. 2.08. What is the ratio of the Expenses (% of total expenses) in Israel in 2010 to that in 2011?
Offer a very short reply. 1.05. What is the ratio of the Expenses (% of total expenses) in Kenya in 2010 to that in 2011?
Make the answer very short. 0.9. What is the ratio of the Expenses (% of total expenses) in San Marino in 2010 to that in 2011?
Offer a very short reply. 1.1. What is the ratio of the Expenses (% of total expenses) in Germany in 2010 to that in 2012?
Provide a succinct answer. 2.09. What is the ratio of the Expenses (% of total expenses) in Israel in 2010 to that in 2012?
Give a very brief answer. 1. What is the ratio of the Expenses (% of total expenses) of Kenya in 2010 to that in 2012?
Keep it short and to the point. 3.31. What is the ratio of the Expenses (% of total expenses) of San Marino in 2010 to that in 2012?
Your answer should be very brief. 1.06. What is the ratio of the Expenses (% of total expenses) of Germany in 2011 to that in 2012?
Offer a very short reply. 1.01. What is the ratio of the Expenses (% of total expenses) in Israel in 2011 to that in 2012?
Ensure brevity in your answer.  0.95. What is the ratio of the Expenses (% of total expenses) in Kenya in 2011 to that in 2012?
Provide a short and direct response. 3.7. What is the ratio of the Expenses (% of total expenses) in San Marino in 2011 to that in 2012?
Keep it short and to the point. 0.97. What is the difference between the highest and the second highest Expenses (% of total expenses) in Germany?
Your answer should be compact. 2.88. What is the difference between the highest and the second highest Expenses (% of total expenses) in Israel?
Provide a succinct answer. 0.45. What is the difference between the highest and the second highest Expenses (% of total expenses) in Kenya?
Your answer should be very brief. 0.85. What is the difference between the highest and the second highest Expenses (% of total expenses) in San Marino?
Offer a very short reply. 4.22. What is the difference between the highest and the lowest Expenses (% of total expenses) in Germany?
Give a very brief answer. 4.05. What is the difference between the highest and the lowest Expenses (% of total expenses) in Israel?
Offer a very short reply. 2.73. What is the difference between the highest and the lowest Expenses (% of total expenses) in Kenya?
Offer a terse response. 3.09. What is the difference between the highest and the lowest Expenses (% of total expenses) in San Marino?
Provide a short and direct response. 9.63. 